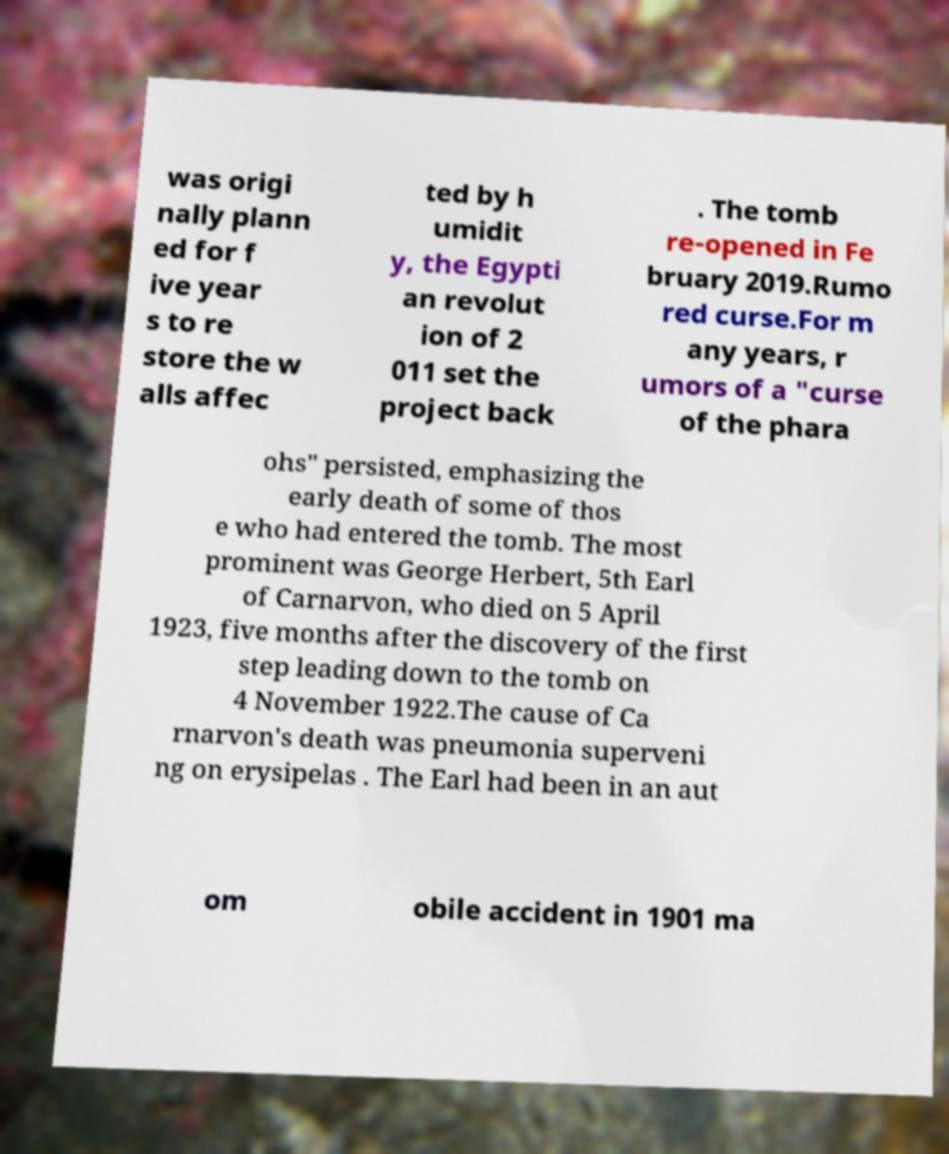There's text embedded in this image that I need extracted. Can you transcribe it verbatim? was origi nally plann ed for f ive year s to re store the w alls affec ted by h umidit y, the Egypti an revolut ion of 2 011 set the project back . The tomb re-opened in Fe bruary 2019.Rumo red curse.For m any years, r umors of a "curse of the phara ohs" persisted, emphasizing the early death of some of thos e who had entered the tomb. The most prominent was George Herbert, 5th Earl of Carnarvon, who died on 5 April 1923, five months after the discovery of the first step leading down to the tomb on 4 November 1922.The cause of Ca rnarvon's death was pneumonia superveni ng on erysipelas . The Earl had been in an aut om obile accident in 1901 ma 